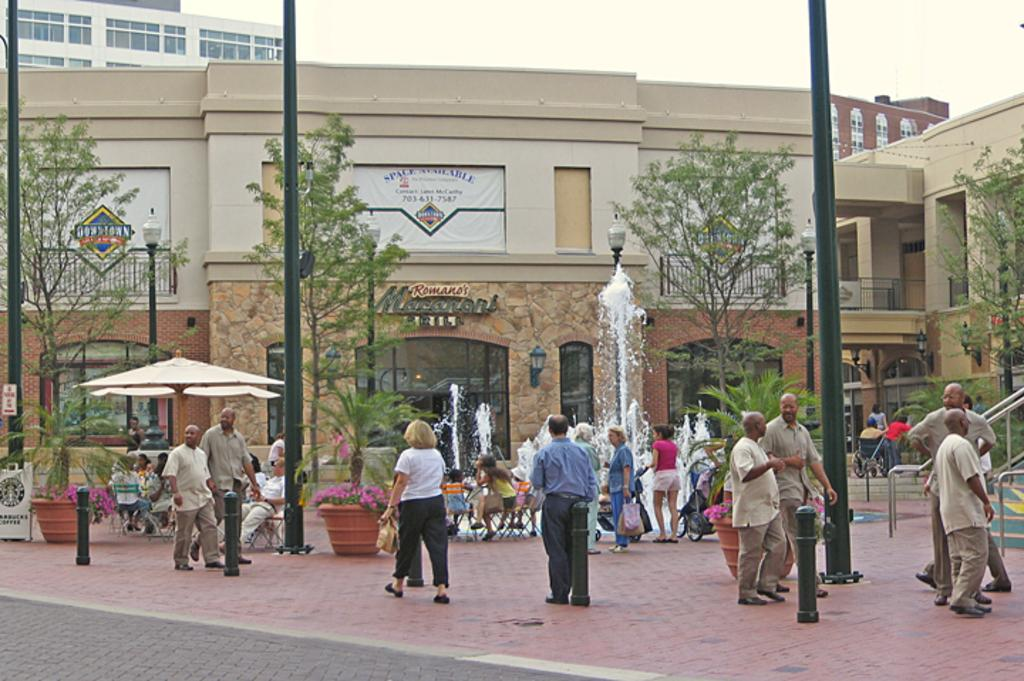What structures can be seen in the image? There are poles, a fountain, and chairs visible in the image. What type of vegetation is present in the image? There are plants, flowers, and trees in the image. Can you describe the water feature in the image? There is a fountain with water visible in the image. What type of seating is available in the image? There are chairs in the image. Are there any people present in the image? Yes, there are people in the image. What can be seen in the background of the image? There are buildings, boards, and the sky visible in the background of the image. Where is the dock located in the image? There is no dock present in the image. What type of milk is being served to the people in the image? There is no milk present in the image. 